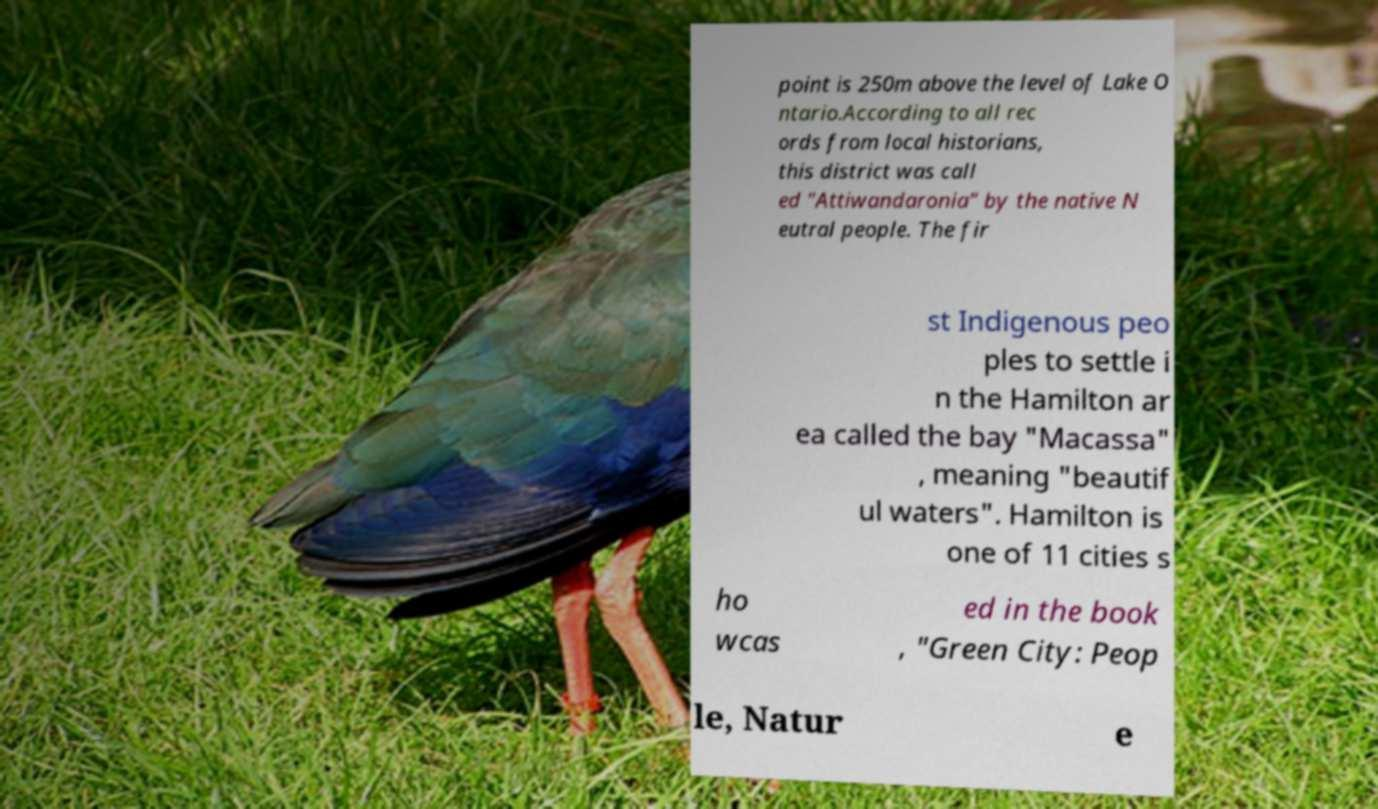I need the written content from this picture converted into text. Can you do that? point is 250m above the level of Lake O ntario.According to all rec ords from local historians, this district was call ed "Attiwandaronia" by the native N eutral people. The fir st Indigenous peo ples to settle i n the Hamilton ar ea called the bay "Macassa" , meaning "beautif ul waters". Hamilton is one of 11 cities s ho wcas ed in the book , "Green City: Peop le, Natur e 